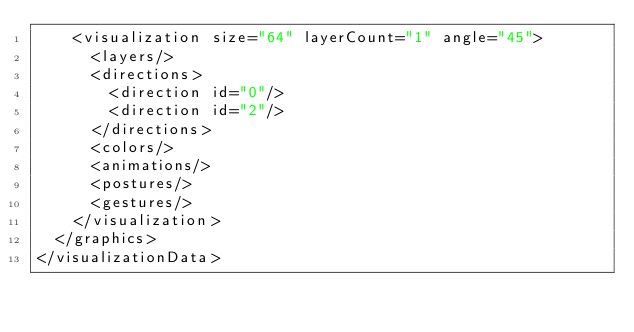Convert code to text. <code><loc_0><loc_0><loc_500><loc_500><_XML_>    <visualization size="64" layerCount="1" angle="45">
      <layers/>
      <directions>
        <direction id="0"/>
        <direction id="2"/>
      </directions>
      <colors/>
      <animations/>
      <postures/>
      <gestures/>
    </visualization>
  </graphics>
</visualizationData></code> 